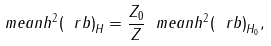Convert formula to latex. <formula><loc_0><loc_0><loc_500><loc_500>\ m e a n { h ^ { 2 } ( \ r b ) } _ { H } = \frac { Z _ { 0 } } { Z } \ m e a n { h ^ { 2 } ( \ r b ) } _ { H _ { 0 } } ,</formula> 